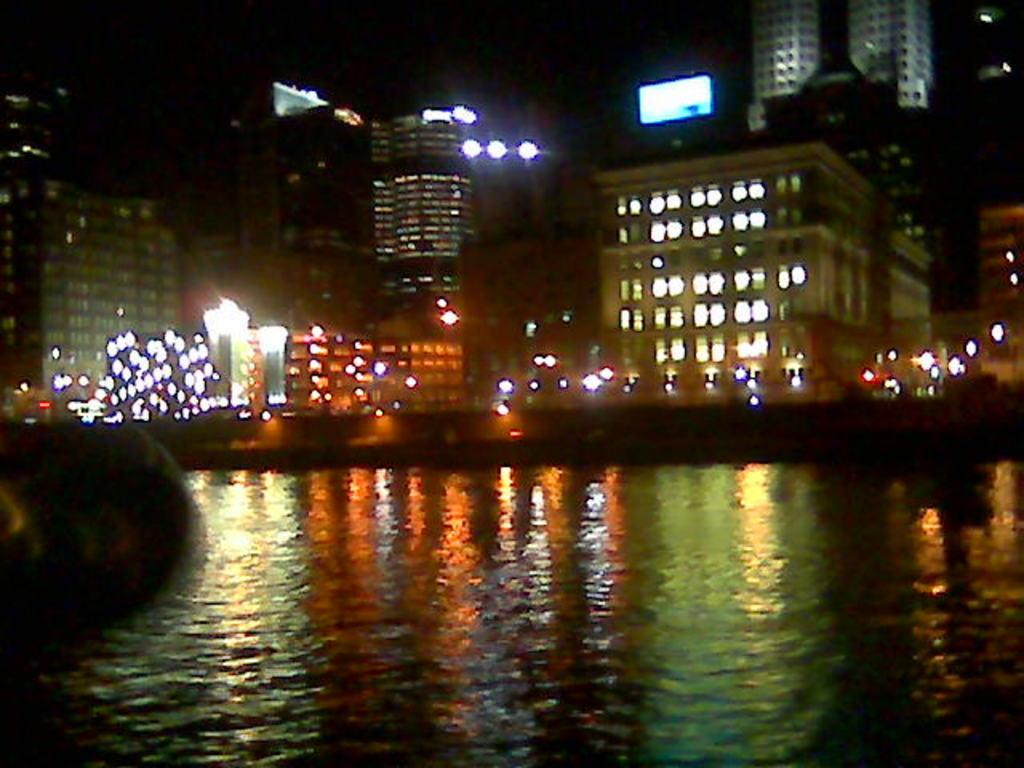What is the main subject in the center of the image? There is water in the center of the image. What can be seen in the distance behind the water? There are buildings in the background of the image. Are there any sources of illumination visible in the image? Yes, there are lights visible in the image. How does the water sort itself in the image? The water does not sort itself in the image; it is a natural body of water. 